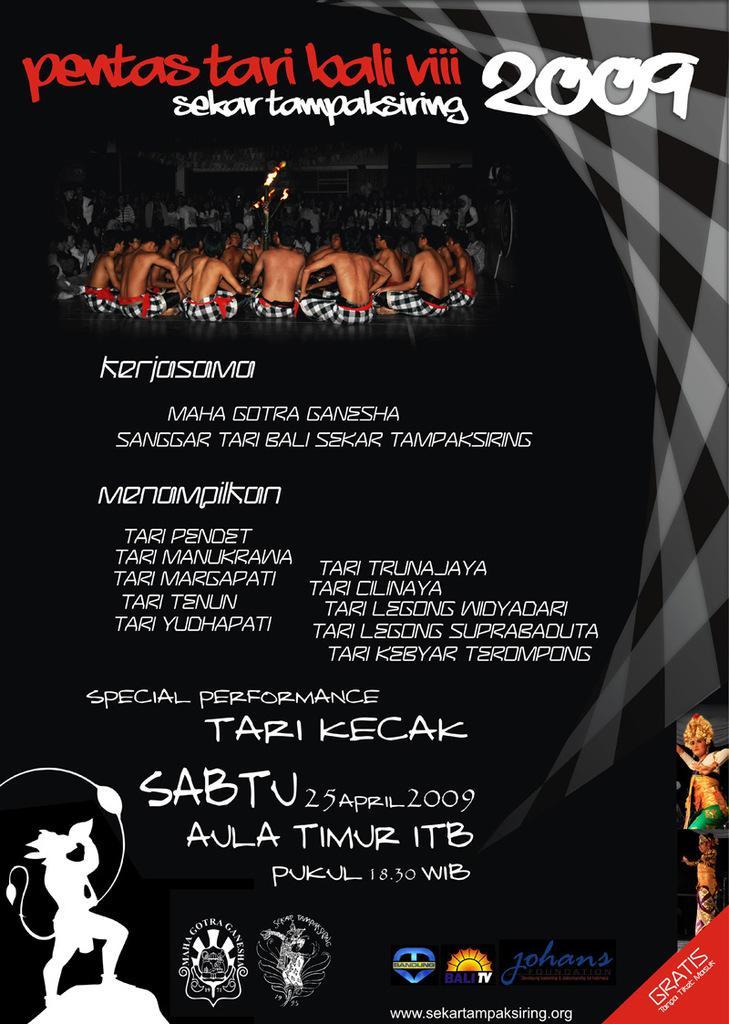Please provide a concise description of this image. In this picture we can observe white and red color text on the black color background. We can observe some people sitting on the floor in this picture. On the left side we can observe an image of lord Hanuman. 